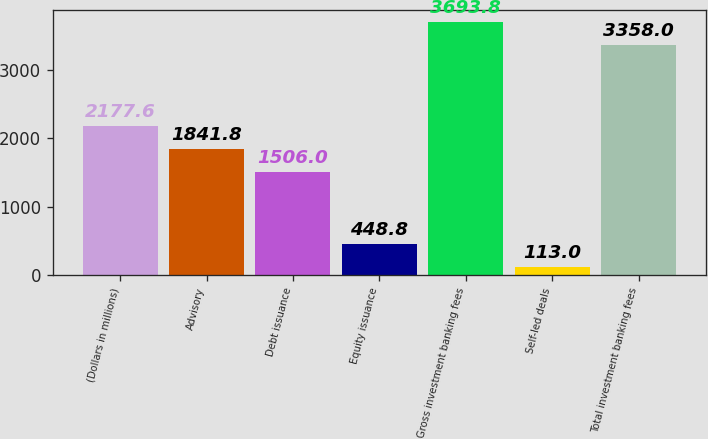Convert chart to OTSL. <chart><loc_0><loc_0><loc_500><loc_500><bar_chart><fcel>(Dollars in millions)<fcel>Advisory<fcel>Debt issuance<fcel>Equity issuance<fcel>Gross investment banking fees<fcel>Self-led deals<fcel>Total investment banking fees<nl><fcel>2177.6<fcel>1841.8<fcel>1506<fcel>448.8<fcel>3693.8<fcel>113<fcel>3358<nl></chart> 